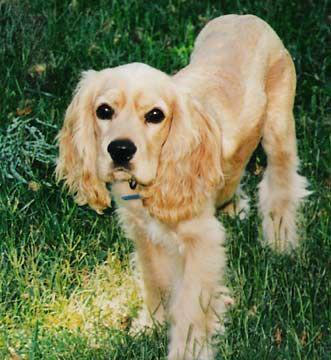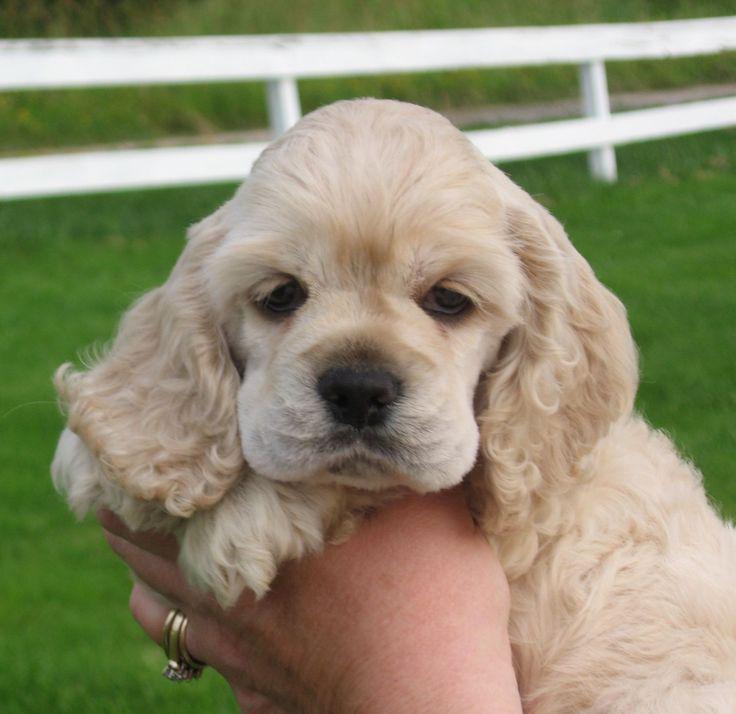The first image is the image on the left, the second image is the image on the right. For the images shown, is this caption "There is a fence in the background of one of the images." true? Answer yes or no. Yes. 